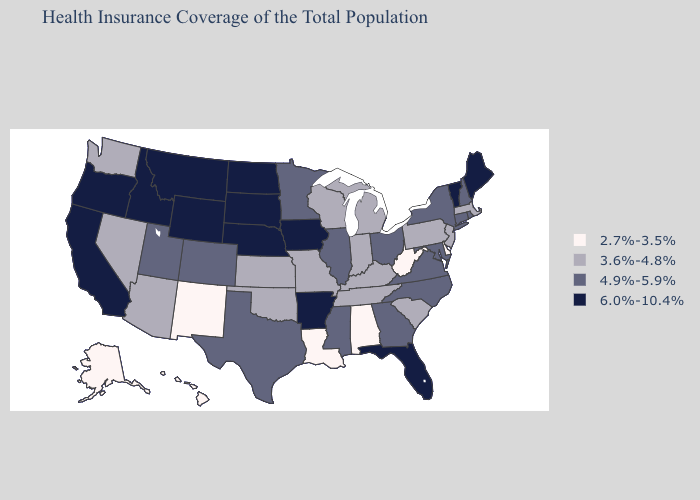Does Connecticut have the lowest value in the Northeast?
Be succinct. No. What is the lowest value in states that border Delaware?
Answer briefly. 3.6%-4.8%. Does Louisiana have the lowest value in the South?
Answer briefly. Yes. What is the value of South Carolina?
Write a very short answer. 3.6%-4.8%. What is the value of Alaska?
Write a very short answer. 2.7%-3.5%. What is the value of Arkansas?
Concise answer only. 6.0%-10.4%. Among the states that border Connecticut , does Rhode Island have the highest value?
Answer briefly. Yes. What is the value of Oregon?
Give a very brief answer. 6.0%-10.4%. Name the states that have a value in the range 3.6%-4.8%?
Concise answer only. Arizona, Indiana, Kansas, Kentucky, Massachusetts, Michigan, Missouri, Nevada, New Jersey, Oklahoma, Pennsylvania, South Carolina, Tennessee, Washington, Wisconsin. What is the lowest value in the West?
Keep it brief. 2.7%-3.5%. Does South Dakota have the highest value in the MidWest?
Keep it brief. Yes. Does Kentucky have a lower value than Massachusetts?
Be succinct. No. What is the value of Louisiana?
Keep it brief. 2.7%-3.5%. Does the first symbol in the legend represent the smallest category?
Give a very brief answer. Yes. What is the value of New Hampshire?
Keep it brief. 4.9%-5.9%. 